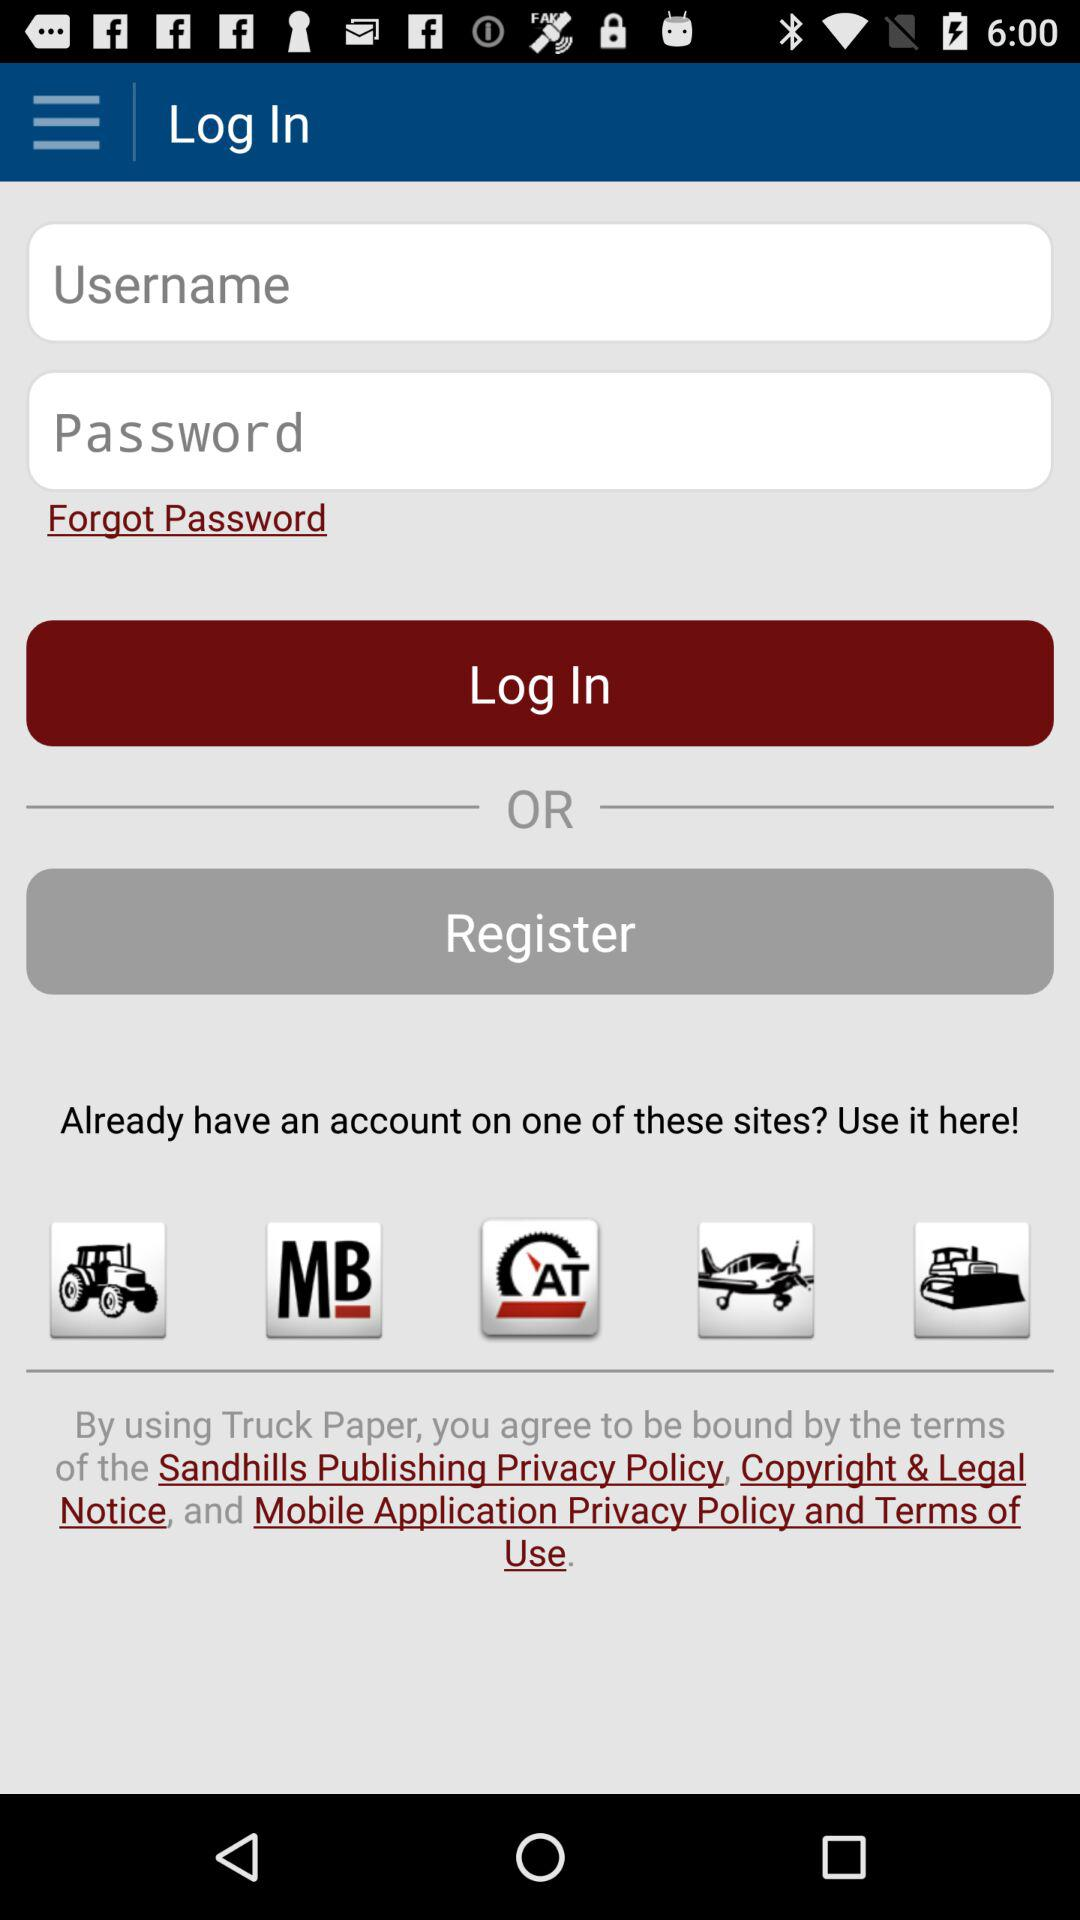How many input fields are there for user credentials?
Answer the question using a single word or phrase. 2 